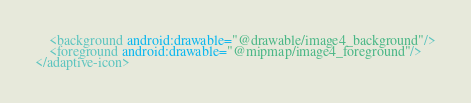<code> <loc_0><loc_0><loc_500><loc_500><_XML_>    <background android:drawable="@drawable/image4_background"/>
    <foreground android:drawable="@mipmap/image4_foreground"/>
</adaptive-icon></code> 